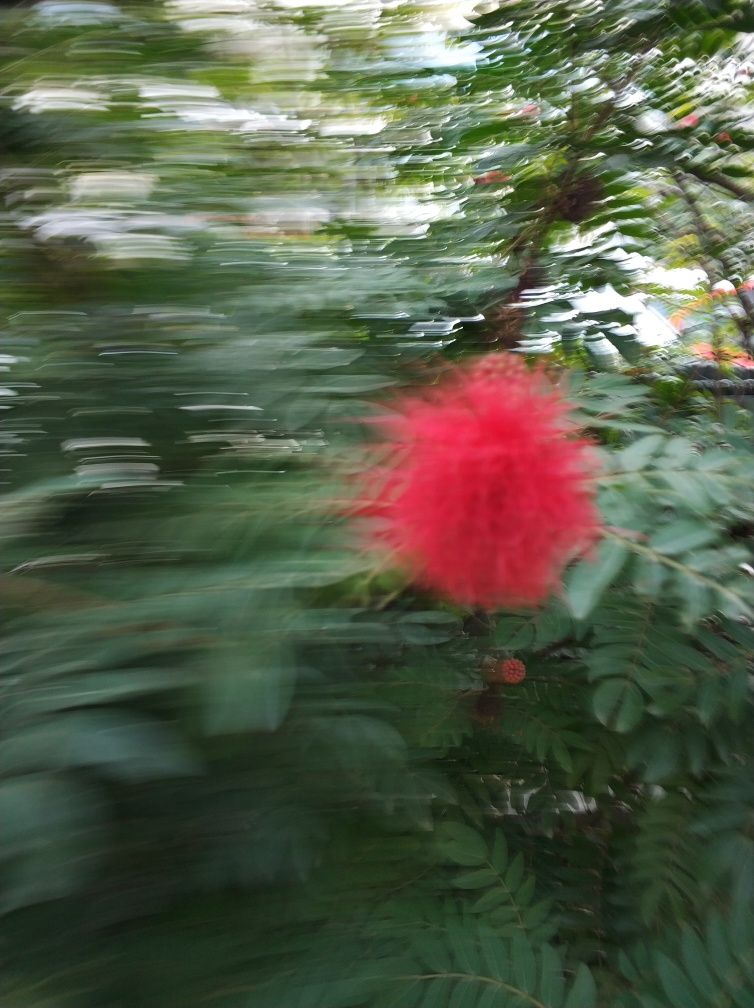What might be the reason for the blurriness of this photo? The blurriness in the photo appears to be the result of motion blur, which may have been caused by camera movement during the exposure. This could be due to the photographer intentionally moving the camera to achieve an artistic effect or an accidental shake while taking the picture. 